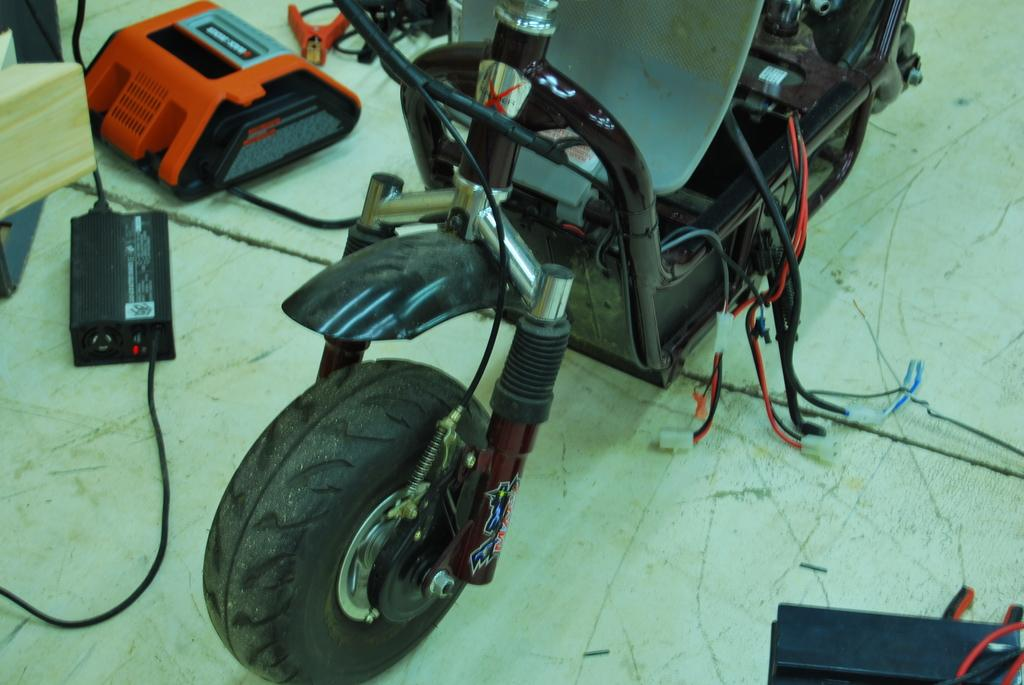What type of vehicle is in the image? The image contains a vehicle, but the specific type cannot be determined from the provided facts. What feature can be seen at the front of the vehicle? The vehicle has a wheel in the front. What is present in the middle of the vehicle? There are wires in the middle of the vehicle. What is at the bottom of the vehicle? The vehicle has a floor at the bottom. What can be found on the left side of the vehicle? There are machines on the left side of the vehicle. What type of cheese is being used to power the vehicle in the image? There is no cheese present in the image, and the vehicle is not powered by cheese. How many slaves are visible working on the vehicle in the image? There are no slaves present in the image, and the vehicle does not involve slave labor. 